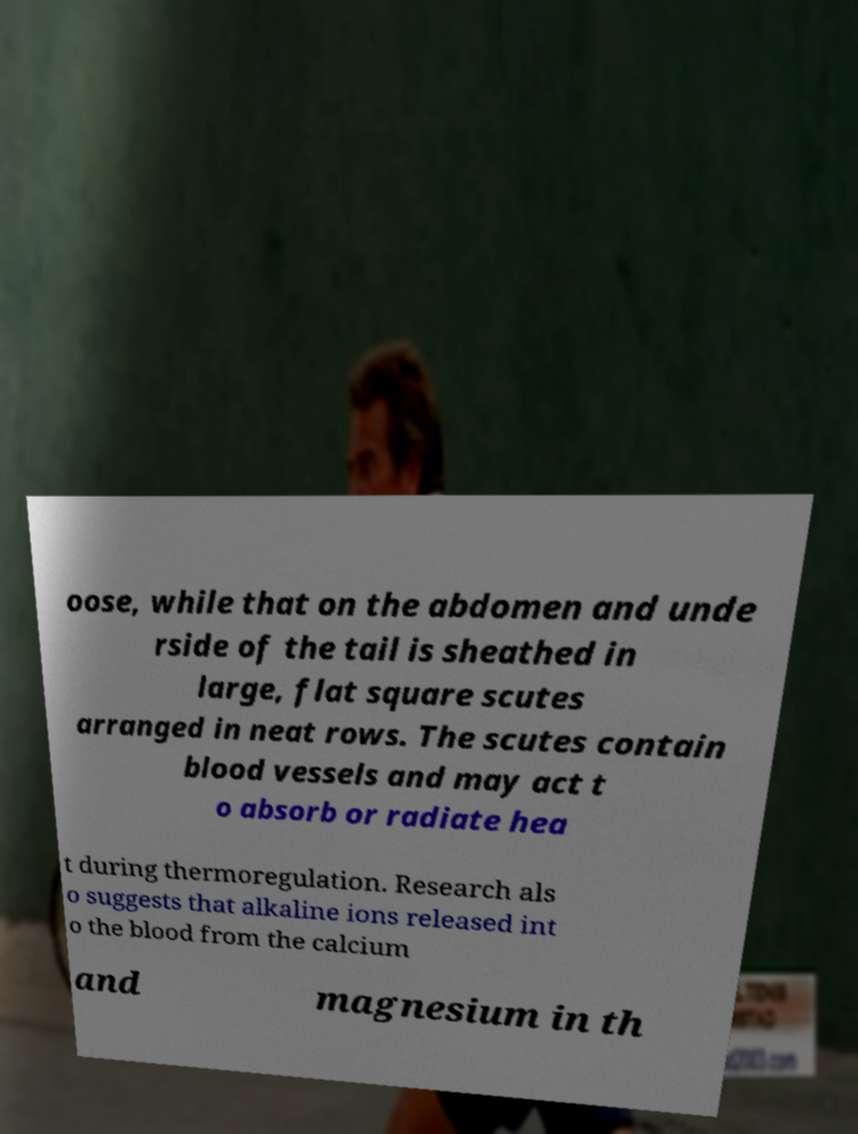Can you read and provide the text displayed in the image?This photo seems to have some interesting text. Can you extract and type it out for me? oose, while that on the abdomen and unde rside of the tail is sheathed in large, flat square scutes arranged in neat rows. The scutes contain blood vessels and may act t o absorb or radiate hea t during thermoregulation. Research als o suggests that alkaline ions released int o the blood from the calcium and magnesium in th 